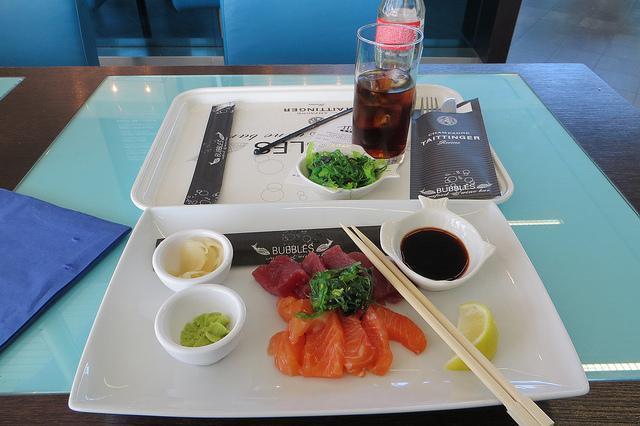How many bowls are there?
Give a very brief answer. 4. How many chairs can you see?
Give a very brief answer. 2. 